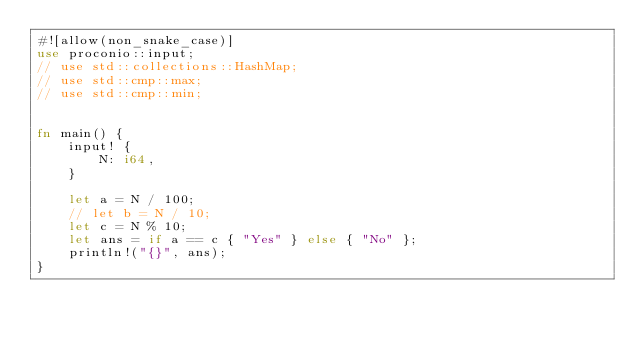<code> <loc_0><loc_0><loc_500><loc_500><_Rust_>#![allow(non_snake_case)]
use proconio::input;
// use std::collections::HashMap;
// use std::cmp::max;
// use std::cmp::min;


fn main() {
    input! {
        N: i64,
    }

    let a = N / 100;
    // let b = N / 10;
    let c = N % 10;
    let ans = if a == c { "Yes" } else { "No" };
    println!("{}", ans);
}
</code> 